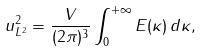<formula> <loc_0><loc_0><loc_500><loc_500>\| u \| ^ { 2 } _ { L ^ { 2 } } = \frac { V } { ( 2 \pi ) ^ { 3 } } \int _ { 0 } ^ { + \infty } E ( \kappa ) \, d \kappa ,</formula> 